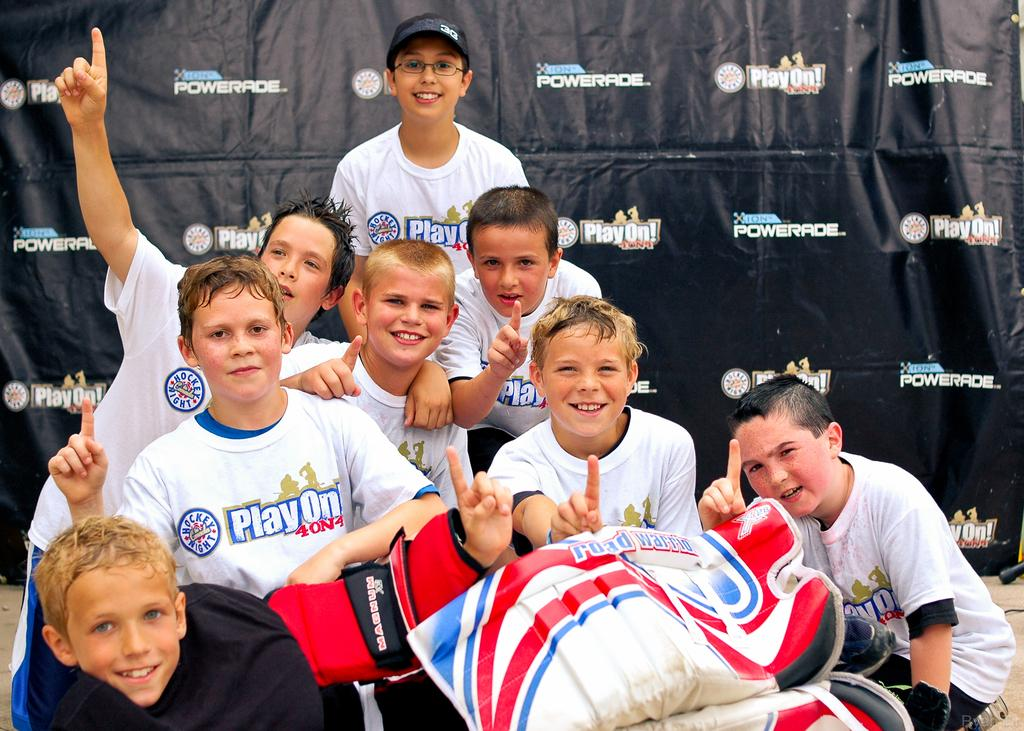<image>
Create a compact narrative representing the image presented. a group of children wearing white shirts that say play on posing for a photo 